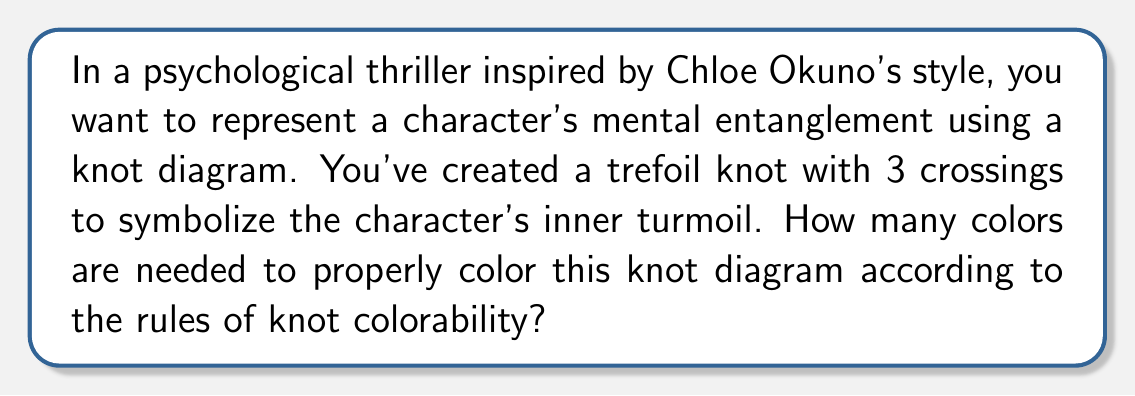Provide a solution to this math problem. To solve this problem, let's follow these steps:

1. Understand the rules of knot colorability:
   - Each arc of the knot must be assigned a color.
   - At each crossing, either all three arcs have the same color, or all three have different colors.

2. Identify the knot:
   The trefoil knot is the simplest non-trivial knot, with a minimal crossing number of 3.

3. Analyze the trefoil knot diagram:
   [asy]
   import geometry;

   path p = (0,0)..(-1,1)..(0,2)..(1,1)..(0,0);
   draw(p, linewidth(2));
   draw((-0.5,0.5)--(0.5,1.5), linewidth(2));
   draw((0.5,0.5)--(-0.5,1.5), linewidth(2));
   draw((0,0.3)--(0,1.7), linewidth(2));
   [/asy]

4. Apply the colorability rules:
   - Let's start by assigning color A to one arc.
   - At the first crossing, we need two more colors, B and C.
   - Following the knot, we see that these three colors are sufficient to color all arcs while satisfying the rules.

5. Verify the coloring:
   - Each crossing has three different colors meeting at it.
   - No two adjacent arcs have the same color.

6. Conclude:
   The minimum number of colors needed to properly color the trefoil knot is 3.

This representation symbolizes the character's complex psychological state, with each color potentially representing different aspects of their personality or conflicting emotions.
Answer: 3 colors 